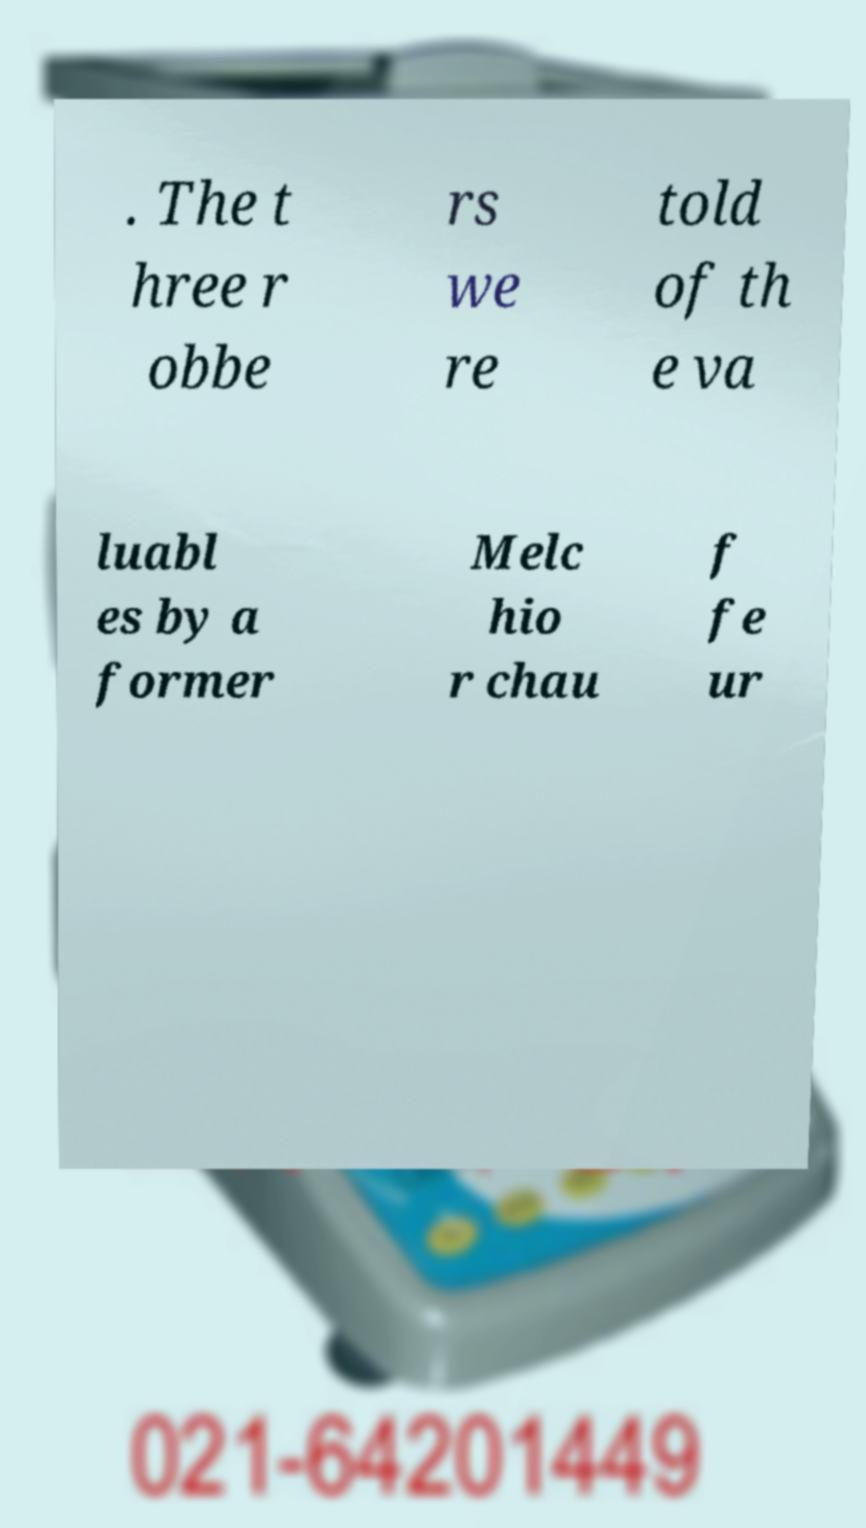What messages or text are displayed in this image? I need them in a readable, typed format. . The t hree r obbe rs we re told of th e va luabl es by a former Melc hio r chau f fe ur 